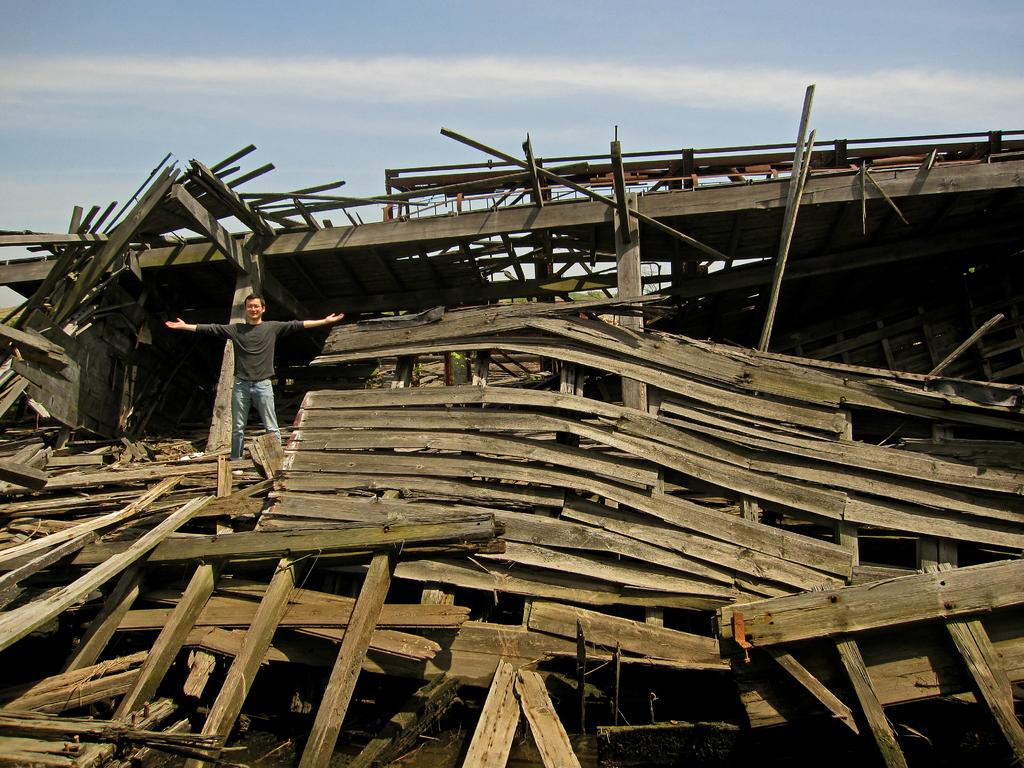What objects are scattered in the image? There are broken wooden sticks and planks in the image. What is the man in the image doing? A man is standing on the wooden sticks and planks. What is the man wearing? The man is wearing a black T-shirt. What can be seen in the background of the image? There is a sky visible in the image, and clouds are present in the sky. What type of badge is the man wearing in the image? There is no badge visible in the image; the man is only wearing a black T-shirt. Can you tell me how many kitties are playing with the wooden sticks in the image? There are no kitties present in the image; it features broken wooden sticks and planks with a man standing on them. 